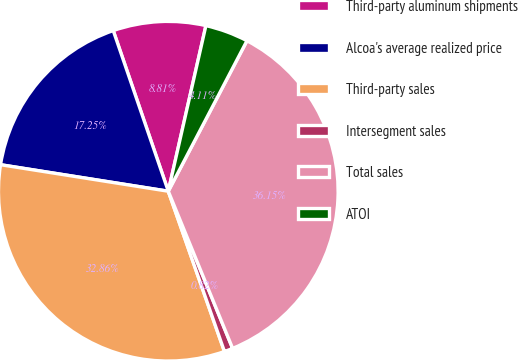<chart> <loc_0><loc_0><loc_500><loc_500><pie_chart><fcel>Third-party aluminum shipments<fcel>Alcoa's average realized price<fcel>Third-party sales<fcel>Intersegment sales<fcel>Total sales<fcel>ATOI<nl><fcel>8.81%<fcel>17.25%<fcel>32.86%<fcel>0.82%<fcel>36.15%<fcel>4.11%<nl></chart> 